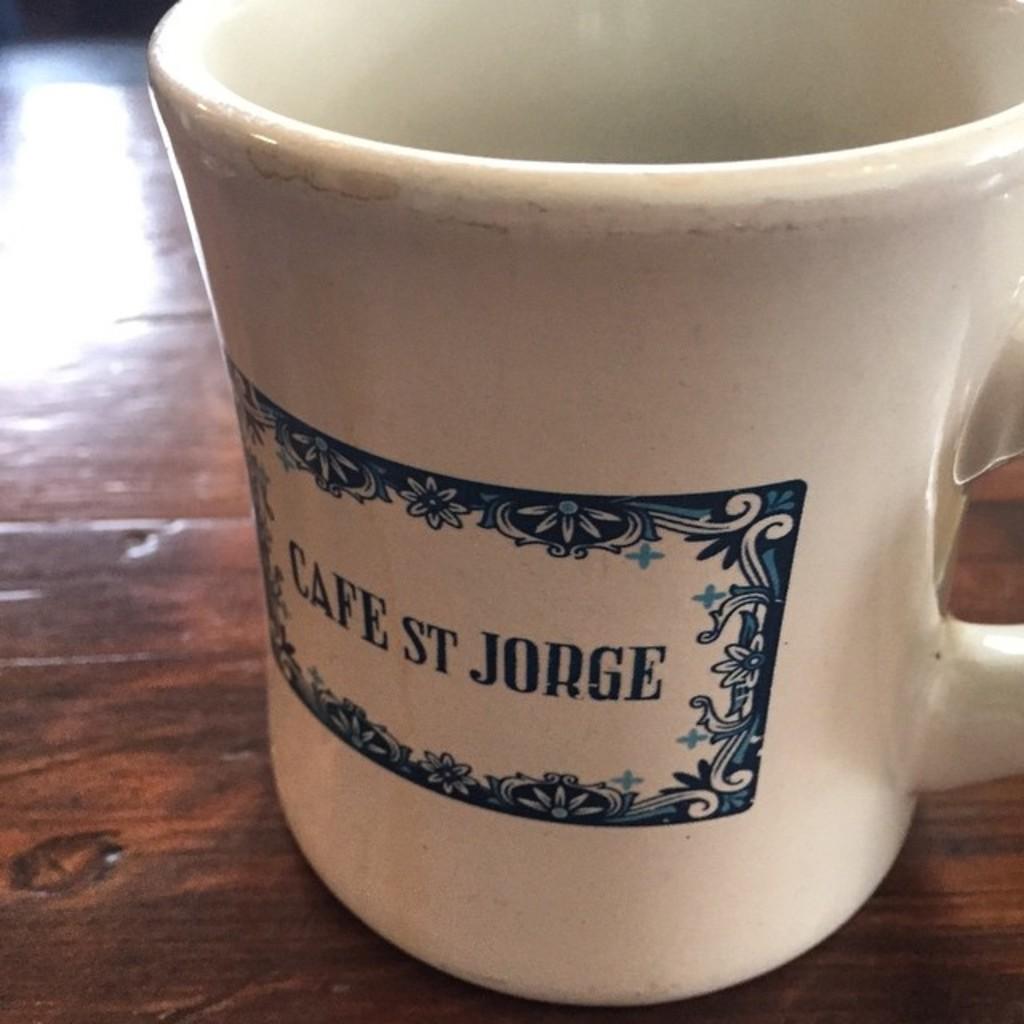What does the mug say?
Provide a short and direct response. Cafe st jorge. 